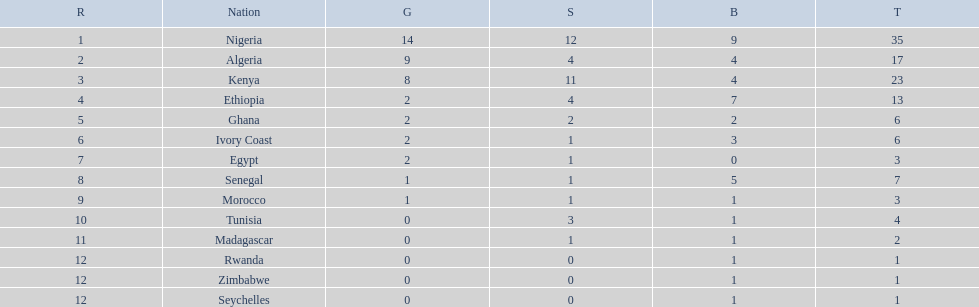What nations competed at the 1989 african championships in athletics? Nigeria, Algeria, Kenya, Ethiopia, Ghana, Ivory Coast, Egypt, Senegal, Morocco, Tunisia, Madagascar, Rwanda, Zimbabwe, Seychelles. What nations earned bronze medals? Nigeria, Algeria, Kenya, Ethiopia, Ghana, Ivory Coast, Senegal, Morocco, Tunisia, Madagascar, Rwanda, Zimbabwe, Seychelles. What nation did not earn a bronze medal? Egypt. 